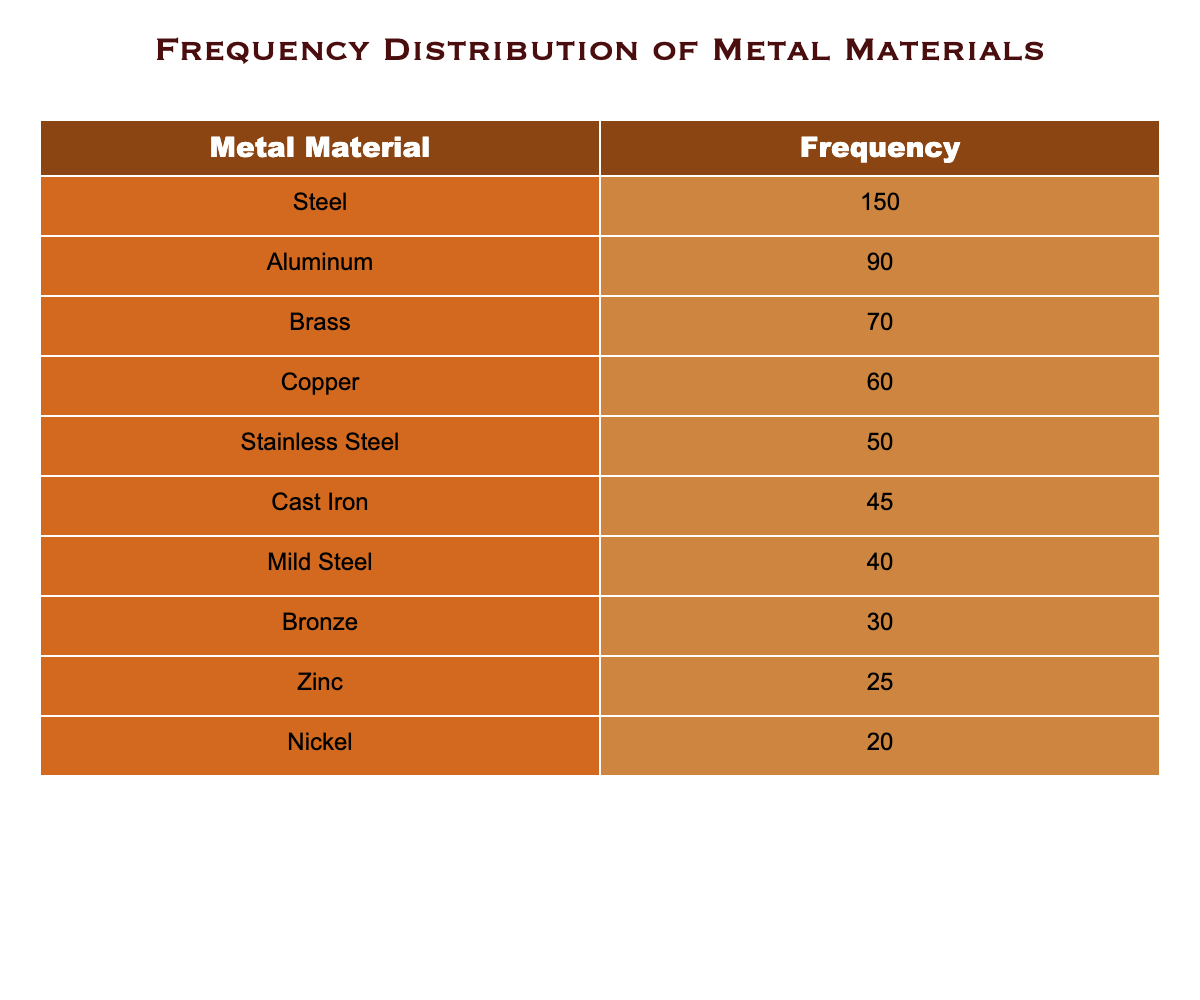What is the frequency of Steel in the table? The table indicates that Steel has a frequency value listed next to it. Referring to the row for Steel, the value is 150.
Answer: 150 What is the least used metal material according to the table? In the table, I can check the frequency of each metal material. The material with the lowest frequency is Nickel, which has a frequency of 20.
Answer: Nickel What is the total frequency of metals that have a frequency greater than 50? I will first identify the metals with a frequency greater than 50: Steel (150), Aluminum (90), Brass (70), and Copper (60). Now, I add these values together: 150 + 90 + 70 + 60 = 370.
Answer: 370 Is the frequency of Cast Iron greater than that of Mild Steel? I will compare the frequency values for Cast Iron (45) and Mild Steel (40). Since 45 is greater than 40, the answer is yes.
Answer: Yes What is the average frequency of the materials listed in the table? To find the average, I will sum all the frequencies: 150 + 90 + 70 + 60 + 50 + 45 + 40 + 30 + 25 + 20 = 570. There are 10 materials in total, so the average is calculated as 570/10 = 57.
Answer: 57 How many metals have a frequency less than 30? By examining the table, only Nickel (20) has a frequency listed below 30, thus only one metal meets this criterion.
Answer: 1 What is the total frequency of Brass and Copper combined? I will add the frequencies for Brass (70) and Copper (60) together. Summing these values gives me 70 + 60 = 130.
Answer: 130 Which material has a frequency exactly 25? I will check each frequency in the table. The material with a frequency of exactly 25 is Zinc.
Answer: Zinc How many more times frequent is Steel compared to Stainless Steel? Steel has a frequency of 150 and Stainless Steel has a frequency of 50. To find how many more times, I divide the frequency of Steel by that of Stainless Steel, which is 150/50 = 3.
Answer: 3 